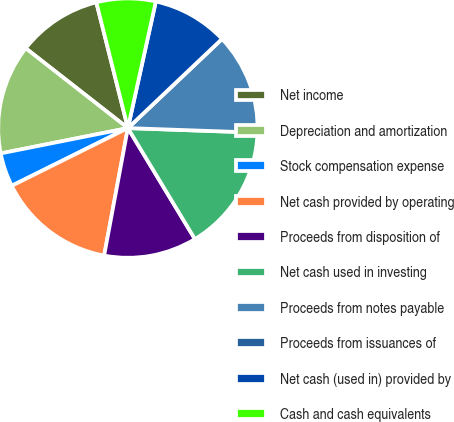<chart> <loc_0><loc_0><loc_500><loc_500><pie_chart><fcel>Net income<fcel>Depreciation and amortization<fcel>Stock compensation expense<fcel>Net cash provided by operating<fcel>Proceeds from disposition of<fcel>Net cash used in investing<fcel>Proceeds from notes payable<fcel>Proceeds from issuances of<fcel>Net cash (used in) provided by<fcel>Cash and cash equivalents<nl><fcel>10.53%<fcel>13.68%<fcel>4.21%<fcel>14.73%<fcel>11.58%<fcel>15.79%<fcel>12.63%<fcel>0.0%<fcel>9.47%<fcel>7.37%<nl></chart> 